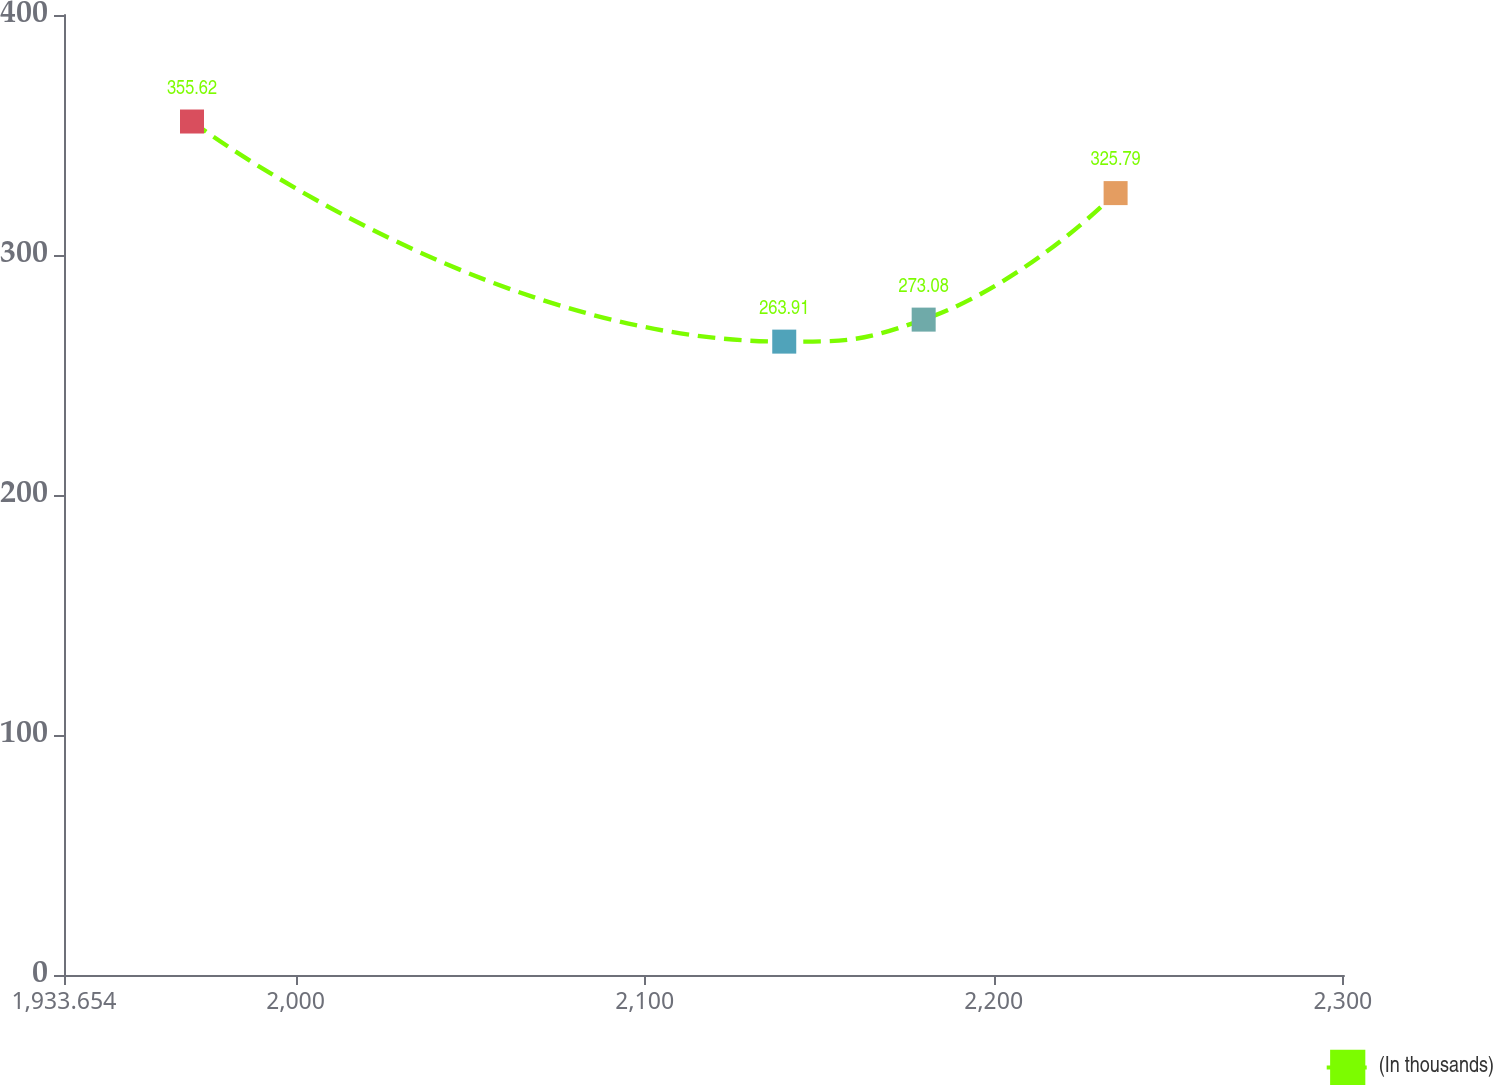Convert chart. <chart><loc_0><loc_0><loc_500><loc_500><line_chart><ecel><fcel>(In thousands)<nl><fcel>1970.32<fcel>355.62<nl><fcel>2139.97<fcel>263.91<nl><fcel>2179.91<fcel>273.08<nl><fcel>2234.89<fcel>325.79<nl><fcel>2336.98<fcel>314.38<nl></chart> 